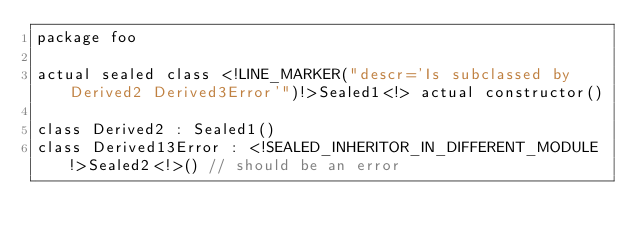Convert code to text. <code><loc_0><loc_0><loc_500><loc_500><_Kotlin_>package foo

actual sealed class <!LINE_MARKER("descr='Is subclassed by Derived2 Derived3Error'")!>Sealed1<!> actual constructor()

class Derived2 : Sealed1()
class Derived13Error : <!SEALED_INHERITOR_IN_DIFFERENT_MODULE!>Sealed2<!>() // should be an error
</code> 